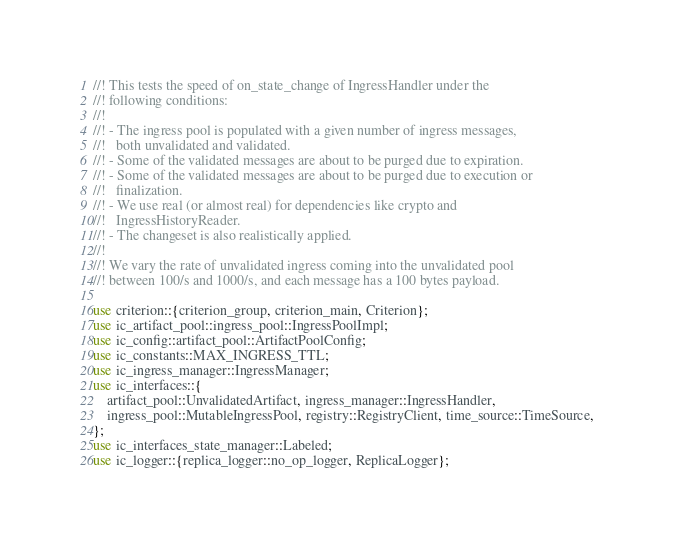<code> <loc_0><loc_0><loc_500><loc_500><_Rust_>//! This tests the speed of on_state_change of IngressHandler under the
//! following conditions:
//!
//! - The ingress pool is populated with a given number of ingress messages,
//!   both unvalidated and validated.
//! - Some of the validated messages are about to be purged due to expiration.
//! - Some of the validated messages are about to be purged due to execution or
//!   finalization.
//! - We use real (or almost real) for dependencies like crypto and
//!   IngressHistoryReader.
//! - The changeset is also realistically applied.
//!
//! We vary the rate of unvalidated ingress coming into the unvalidated pool
//! between 100/s and 1000/s, and each message has a 100 bytes payload.

use criterion::{criterion_group, criterion_main, Criterion};
use ic_artifact_pool::ingress_pool::IngressPoolImpl;
use ic_config::artifact_pool::ArtifactPoolConfig;
use ic_constants::MAX_INGRESS_TTL;
use ic_ingress_manager::IngressManager;
use ic_interfaces::{
    artifact_pool::UnvalidatedArtifact, ingress_manager::IngressHandler,
    ingress_pool::MutableIngressPool, registry::RegistryClient, time_source::TimeSource,
};
use ic_interfaces_state_manager::Labeled;
use ic_logger::{replica_logger::no_op_logger, ReplicaLogger};</code> 